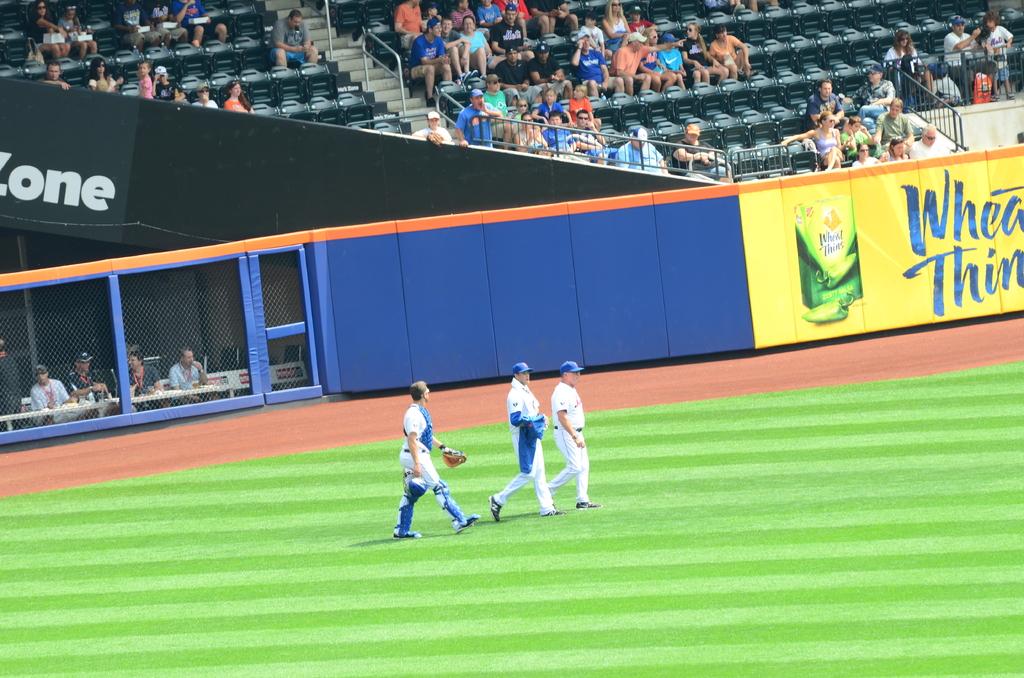What advertisement is on the backboard in yellow?
Your answer should be compact. Wheat thins. Is part of the word on the left "one"?
Your answer should be compact. Yes. 